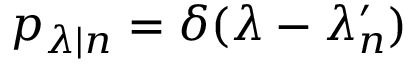<formula> <loc_0><loc_0><loc_500><loc_500>p _ { \lambda | n } = \delta ( \lambda - \lambda _ { n } ^ { \prime } )</formula> 